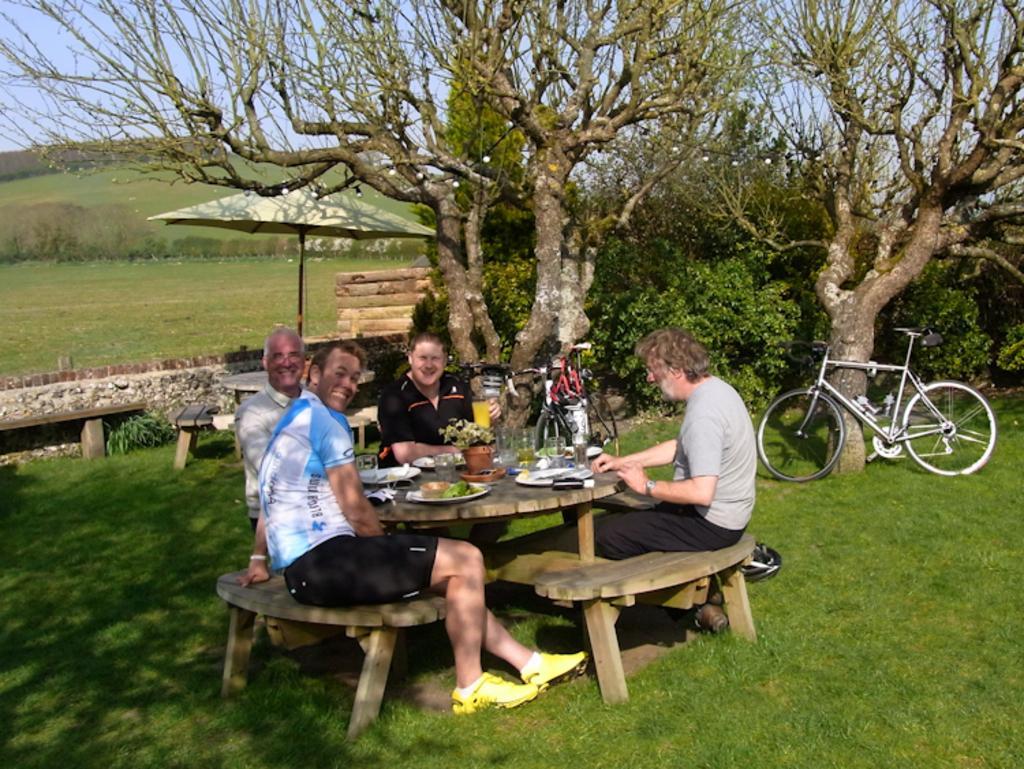Please provide a concise description of this image. There are four persons in the image. They are sitting on bench there is a wooden table in front of them. On that there are glasses,, flower pot, plate with food. The first person is wearing a white t shirt with a black short. He is wearing yellow shoes. He is smiling. The second person is wearing white shirt. He is also smiling. The third person is wearing black t shirt. He is having a smiling face. The fourth person is wearing a grey t shirt with black pant. There is a bicycle which is standing with support of a tree. There are trees. There are grasses in the ground. There is a bench. There is one umbrella under it there is table and chair. There are light bulbs. Few more cycles are also there. The weather is clear and the sky is looking fine. 